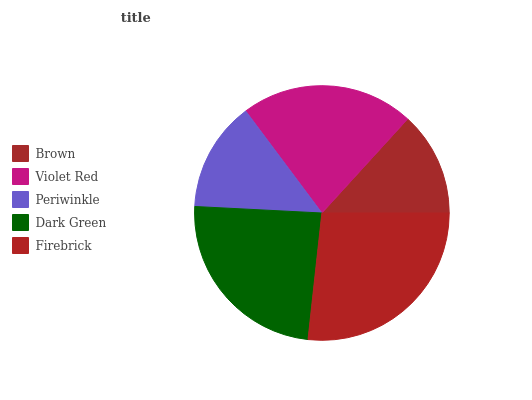Is Brown the minimum?
Answer yes or no. Yes. Is Firebrick the maximum?
Answer yes or no. Yes. Is Violet Red the minimum?
Answer yes or no. No. Is Violet Red the maximum?
Answer yes or no. No. Is Violet Red greater than Brown?
Answer yes or no. Yes. Is Brown less than Violet Red?
Answer yes or no. Yes. Is Brown greater than Violet Red?
Answer yes or no. No. Is Violet Red less than Brown?
Answer yes or no. No. Is Violet Red the high median?
Answer yes or no. Yes. Is Violet Red the low median?
Answer yes or no. Yes. Is Firebrick the high median?
Answer yes or no. No. Is Periwinkle the low median?
Answer yes or no. No. 